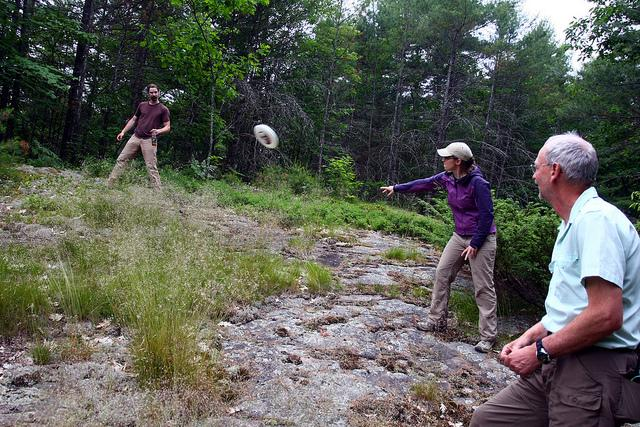Who is standing at a higher level on the rock? Please explain your reasoning. brown shirt. The person in brown is the highest. 